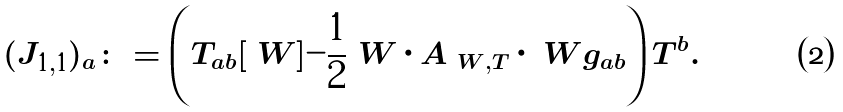<formula> <loc_0><loc_0><loc_500><loc_500>( J _ { 1 , 1 } ) _ { a } \colon = \left ( T _ { a b } [ \ W ] - \frac { 1 } { 2 } \ W \cdot A _ { \ W , T } \cdot \ W g _ { a b } \right ) T ^ { b } .</formula> 